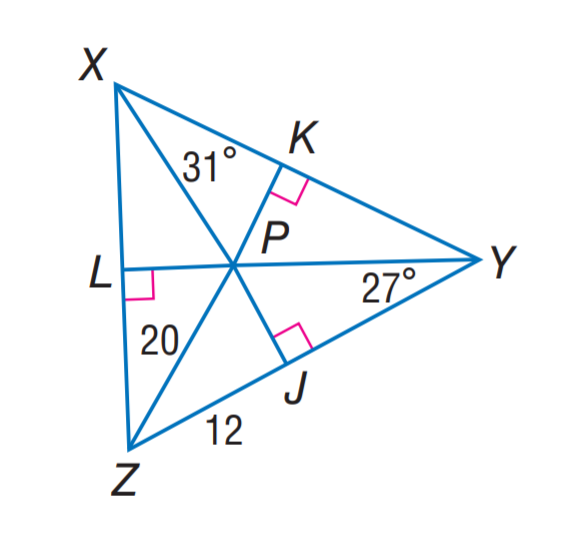Answer the mathemtical geometry problem and directly provide the correct option letter.
Question: P is the incenter of \angle X Y Z. Find m \angle L Z P.
Choices: A: 20 B: 27 C: 31 D: 32 D 